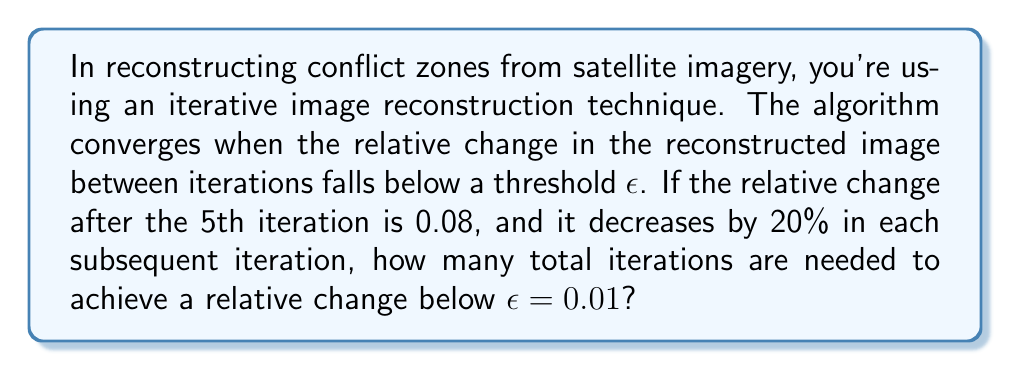Provide a solution to this math problem. Let's approach this step-by-step:

1) The relative change after the 5th iteration is 0.08.

2) In each subsequent iteration, the relative change decreases by 20%. This means that in each iteration, the new relative change is 80% of the previous one.

3) Let's calculate the relative change for each iteration until we reach below 0.01:

   Iteration 5: 0.08
   Iteration 6: $0.08 \times 0.8 = 0.064$
   Iteration 7: $0.064 \times 0.8 = 0.0512$
   Iteration 8: $0.0512 \times 0.8 = 0.04096$
   Iteration 9: $0.04096 \times 0.8 = 0.032768$
   Iteration 10: $0.032768 \times 0.8 = 0.0262144$
   Iteration 11: $0.0262144 \times 0.8 = 0.02097152$
   Iteration 12: $0.02097152 \times 0.8 = 0.016777216$
   Iteration 13: $0.016777216 \times 0.8 = 0.0134217728$
   Iteration 14: $0.0134217728 \times 0.8 = 0.01073741824$
   Iteration 15: $0.01073741824 \times 0.8 = 0.008589934592$

4) We see that after the 15th iteration, the relative change falls below 0.01.

5) Therefore, 15 total iterations are needed to achieve a relative change below $\epsilon = 0.01$.
Answer: 15 iterations 